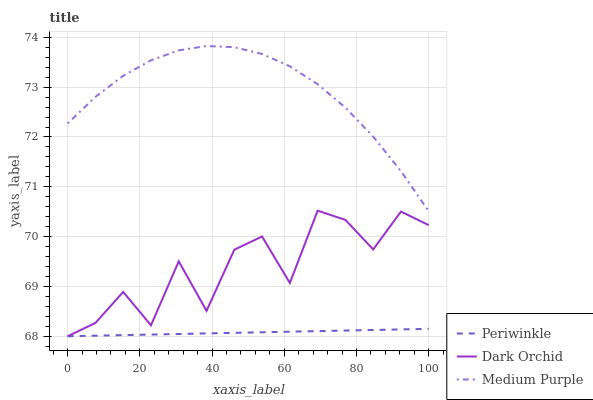Does Periwinkle have the minimum area under the curve?
Answer yes or no. Yes. Does Medium Purple have the maximum area under the curve?
Answer yes or no. Yes. Does Dark Orchid have the minimum area under the curve?
Answer yes or no. No. Does Dark Orchid have the maximum area under the curve?
Answer yes or no. No. Is Periwinkle the smoothest?
Answer yes or no. Yes. Is Dark Orchid the roughest?
Answer yes or no. Yes. Is Dark Orchid the smoothest?
Answer yes or no. No. Is Periwinkle the roughest?
Answer yes or no. No. Does Periwinkle have the lowest value?
Answer yes or no. Yes. Does Medium Purple have the highest value?
Answer yes or no. Yes. Does Dark Orchid have the highest value?
Answer yes or no. No. Is Periwinkle less than Medium Purple?
Answer yes or no. Yes. Is Medium Purple greater than Periwinkle?
Answer yes or no. Yes. Does Dark Orchid intersect Periwinkle?
Answer yes or no. Yes. Is Dark Orchid less than Periwinkle?
Answer yes or no. No. Is Dark Orchid greater than Periwinkle?
Answer yes or no. No. Does Periwinkle intersect Medium Purple?
Answer yes or no. No. 